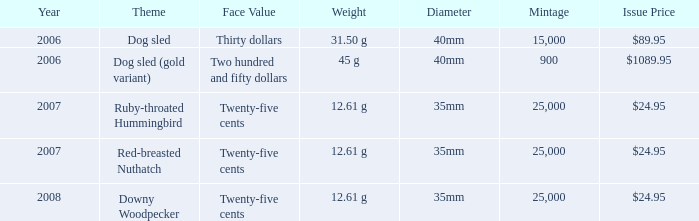What is the Theme of the coin with an Issue Price of $89.95? Dog sled. Could you parse the entire table as a dict? {'header': ['Year', 'Theme', 'Face Value', 'Weight', 'Diameter', 'Mintage', 'Issue Price'], 'rows': [['2006', 'Dog sled', 'Thirty dollars', '31.50 g', '40mm', '15,000', '$89.95'], ['2006', 'Dog sled (gold variant)', 'Two hundred and fifty dollars', '45 g', '40mm', '900', '$1089.95'], ['2007', 'Ruby-throated Hummingbird', 'Twenty-five cents', '12.61 g', '35mm', '25,000', '$24.95'], ['2007', 'Red-breasted Nuthatch', 'Twenty-five cents', '12.61 g', '35mm', '25,000', '$24.95'], ['2008', 'Downy Woodpecker', 'Twenty-five cents', '12.61 g', '35mm', '25,000', '$24.95']]} 